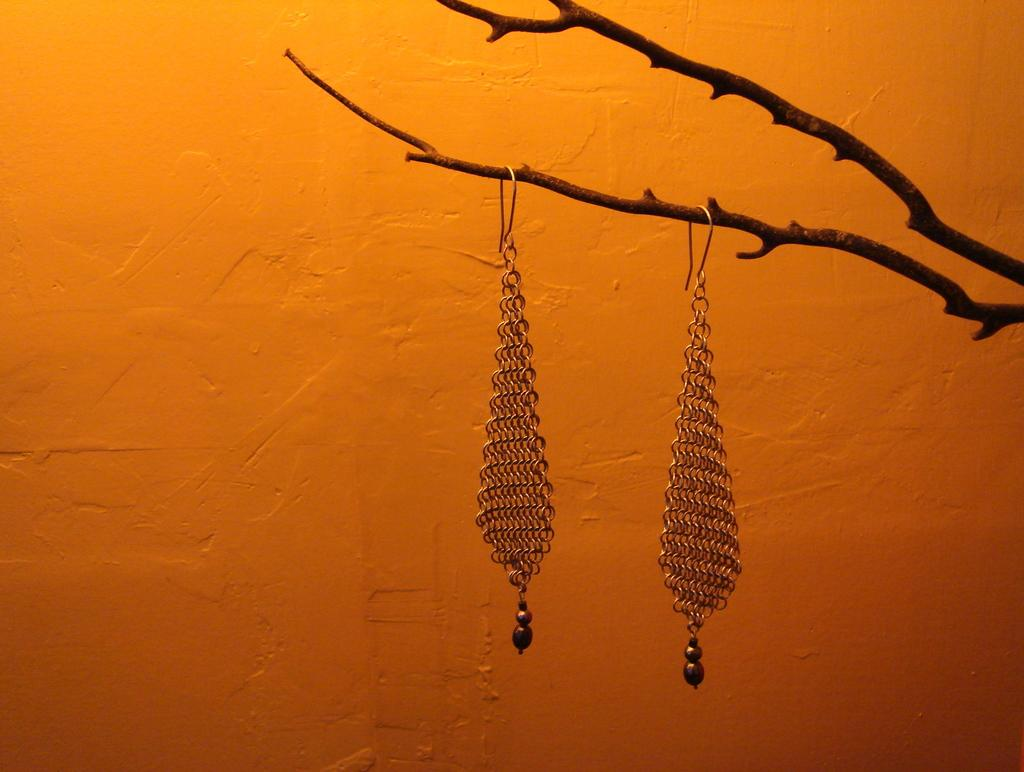What type of accessory is present in the image? There are earrings in the image. Where are the earrings located? The earrings are on a tree branch. What can be seen in the background of the image? There is a wall in the background of the image. Is there a person running with an umbrella in the image? No, there is no person or umbrella present in the image. 